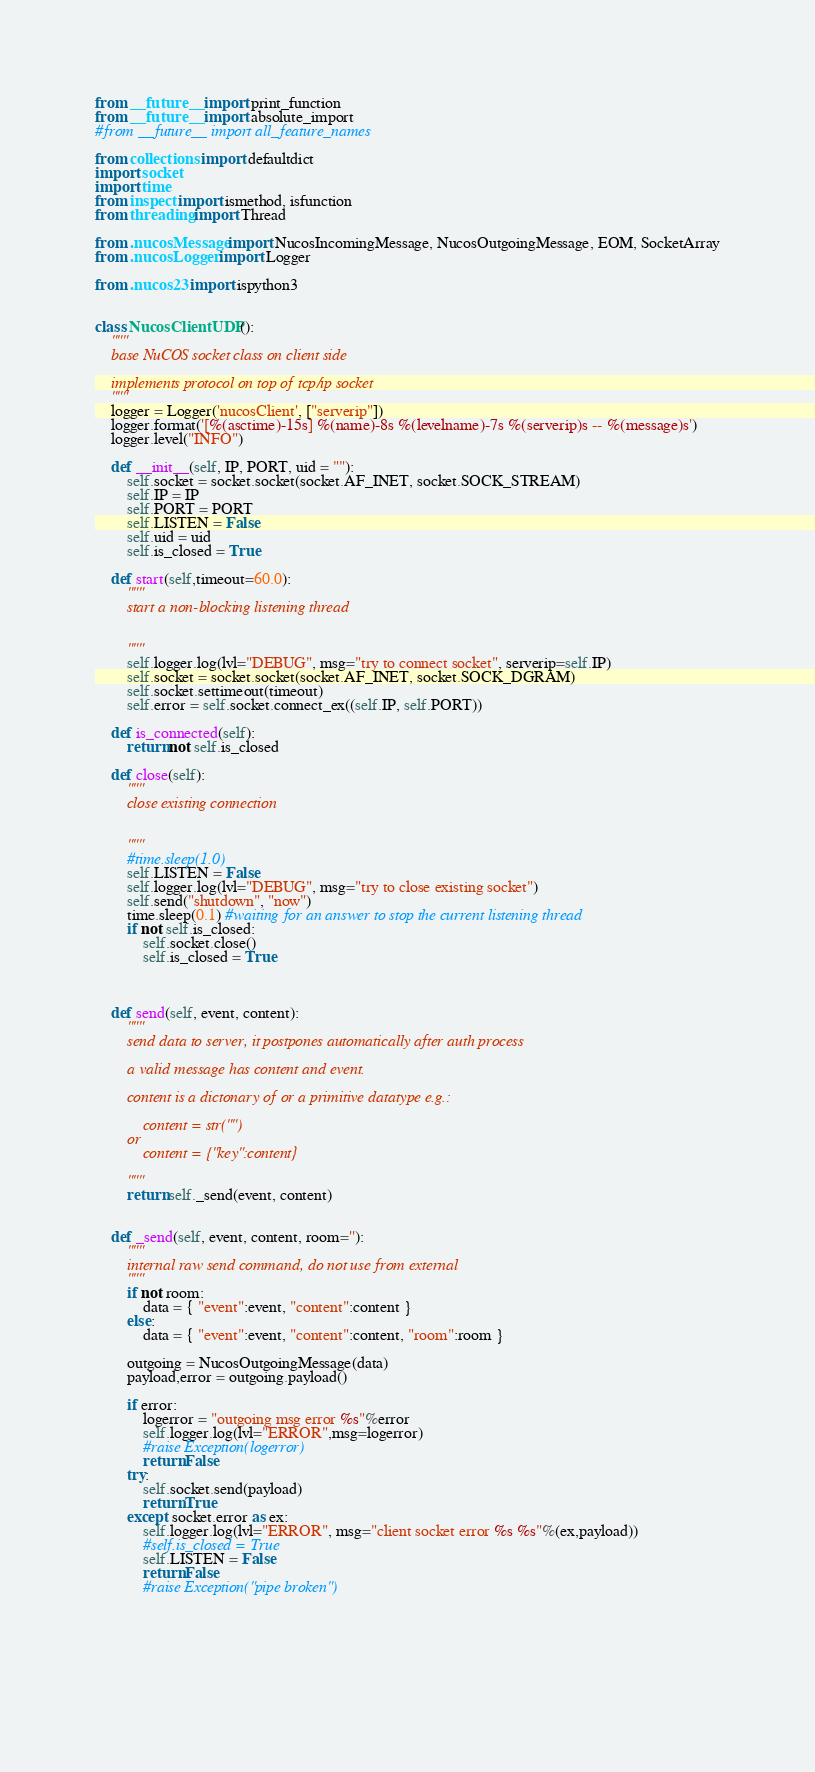Convert code to text. <code><loc_0><loc_0><loc_500><loc_500><_Python_>from __future__ import print_function
from __future__ import absolute_import
#from __future__ import all_feature_names

from collections import defaultdict
import socket
import time
from inspect import ismethod, isfunction
from threading import Thread

from .nucosMessage import NucosIncomingMessage, NucosOutgoingMessage, EOM, SocketArray
from .nucosLogger import Logger

from .nucos23 import ispython3


class NucosClientUDP():
    """
    base NuCOS socket class on client side
    
    implements protocol on top of tcp/ip socket
    """
    logger = Logger('nucosClient', ["serverip"])
    logger.format('[%(asctime)-15s] %(name)-8s %(levelname)-7s %(serverip)s -- %(message)s')
    logger.level("INFO")
    
    def __init__(self, IP, PORT, uid = ""):
        self.socket = socket.socket(socket.AF_INET, socket.SOCK_STREAM)
        self.IP = IP
        self.PORT = PORT
        self.LISTEN = False
        self.uid = uid
        self.is_closed = True
            
    def start(self,timeout=60.0):
        """
        start a non-blocking listening thread
        
        
        """
        self.logger.log(lvl="DEBUG", msg="try to connect socket", serverip=self.IP)
        self.socket = socket.socket(socket.AF_INET, socket.SOCK_DGRAM)
        self.socket.settimeout(timeout)
        self.error = self.socket.connect_ex((self.IP, self.PORT))
        
    def is_connected(self):
        return not self.is_closed
        
    def close(self):
        """
        close existing connection
        
        
        """
        #time.sleep(1.0)
        self.LISTEN = False
        self.logger.log(lvl="DEBUG", msg="try to close existing socket")
        self.send("shutdown", "now")
        time.sleep(0.1) #waiting for an answer to stop the current listening thread
        if not self.is_closed:
            self.socket.close()
            self.is_closed = True
        
        
        
    def send(self, event, content):
        """
        send data to server, it postpones automatically after auth process
        
        a valid message has content and event.
        
        content is a dictonary of or a primitive datatype e.g.: 
        
            content = str("")
        or 
            content = {"key":content}
            
        """
        return self._send(event, content)
        
        
    def _send(self, event, content, room=''):
        """
        internal raw send command, do not use from external
        """
        if not room:
            data = { "event":event, "content":content }
        else:
            data = { "event":event, "content":content, "room":room }

        outgoing = NucosOutgoingMessage(data)        
        payload,error = outgoing.payload()
            
        if error:
            logerror = "outgoing msg error %s"%error
            self.logger.log(lvl="ERROR",msg=logerror)
            #raise Exception(logerror)
            return False
        try:    
            self.socket.send(payload)
            return True
        except socket.error as ex:
            self.logger.log(lvl="ERROR", msg="client socket error %s %s"%(ex,payload))
            #self.is_closed = True
            self.LISTEN = False
            return False
            #raise Exception("pipe broken")
        
        

            
        
        
</code> 